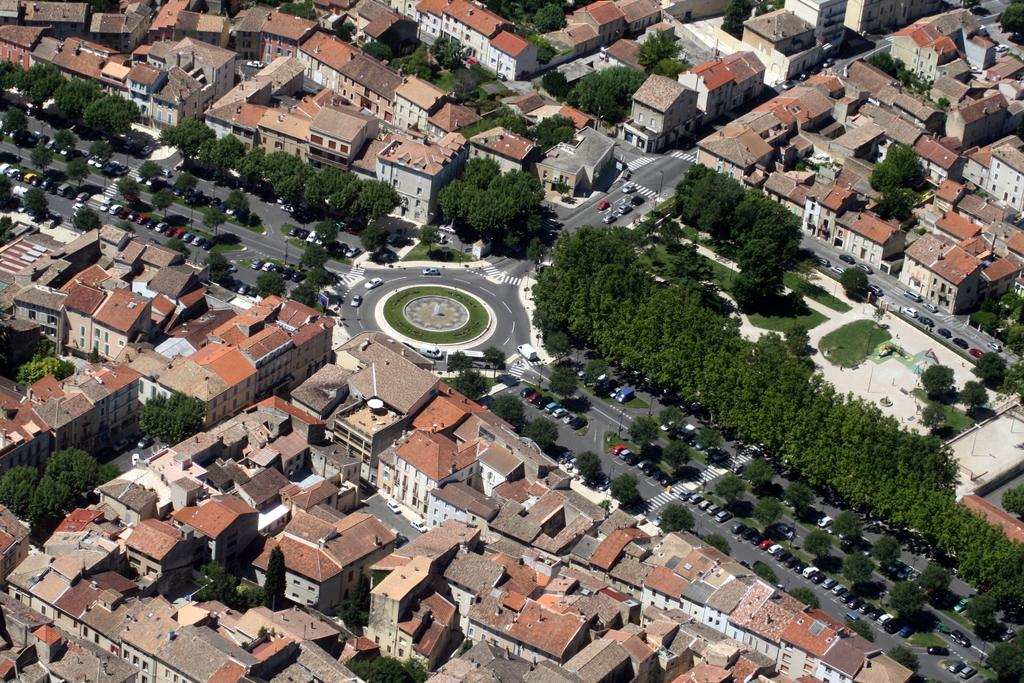What type of view is shown in the image? The image is an aerial view. What structures can be seen in the image? There are buildings in the image. What part of the buildings is visible in the image? Roofs are visible in the image. What type of transportation infrastructure is present in the image? There is a road in the image. What type of natural elements are present in the image? Trees are present in the image. What type of man-made objects are visible in the image? Vehicles are visible in the image. Can you see a squirrel sitting on a table in the image? There is no squirrel or table present in the image. What type of creature is shown interacting with the vehicles in the image? There is no creature shown interacting with the vehicles in the image; only buildings, roofs, roads, trees, and vehicles are present. 